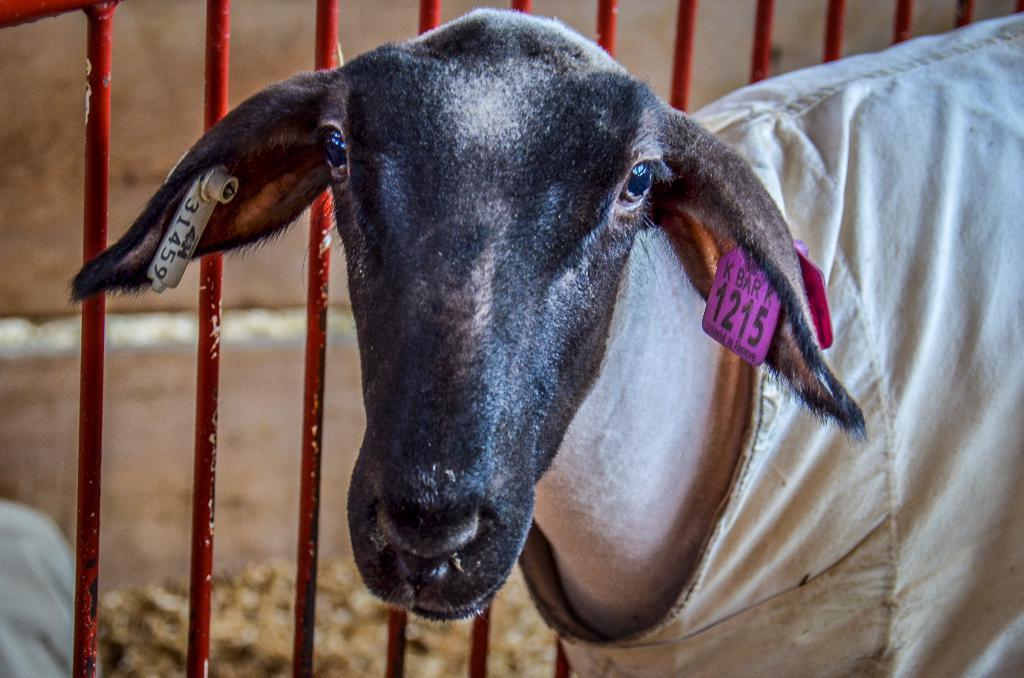Please provide a concise description of this image. In this image we can see the animal with cloth and number tag near the fence and there is the blur background. 